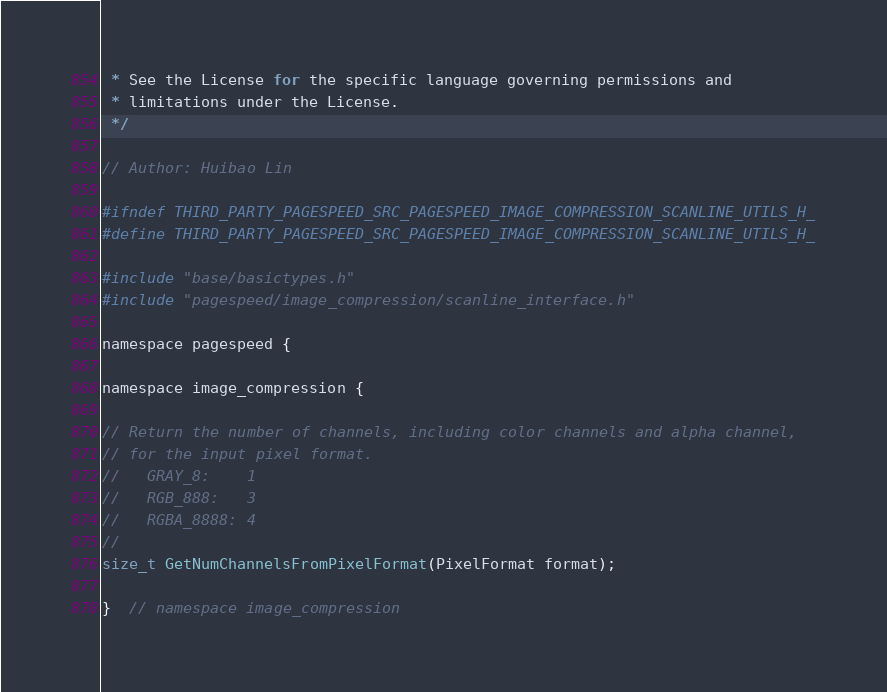Convert code to text. <code><loc_0><loc_0><loc_500><loc_500><_C_> * See the License for the specific language governing permissions and
 * limitations under the License.
 */

// Author: Huibao Lin

#ifndef THIRD_PARTY_PAGESPEED_SRC_PAGESPEED_IMAGE_COMPRESSION_SCANLINE_UTILS_H_
#define THIRD_PARTY_PAGESPEED_SRC_PAGESPEED_IMAGE_COMPRESSION_SCANLINE_UTILS_H_

#include "base/basictypes.h"
#include "pagespeed/image_compression/scanline_interface.h"

namespace pagespeed {

namespace image_compression {

// Return the number of channels, including color channels and alpha channel,
// for the input pixel format.
//   GRAY_8:    1
//   RGB_888:   3
//   RGBA_8888: 4
//
size_t GetNumChannelsFromPixelFormat(PixelFormat format);

}  // namespace image_compression
</code> 